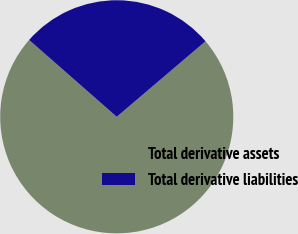Convert chart. <chart><loc_0><loc_0><loc_500><loc_500><pie_chart><fcel>Total derivative assets<fcel>Total derivative liabilities<nl><fcel>72.68%<fcel>27.32%<nl></chart> 